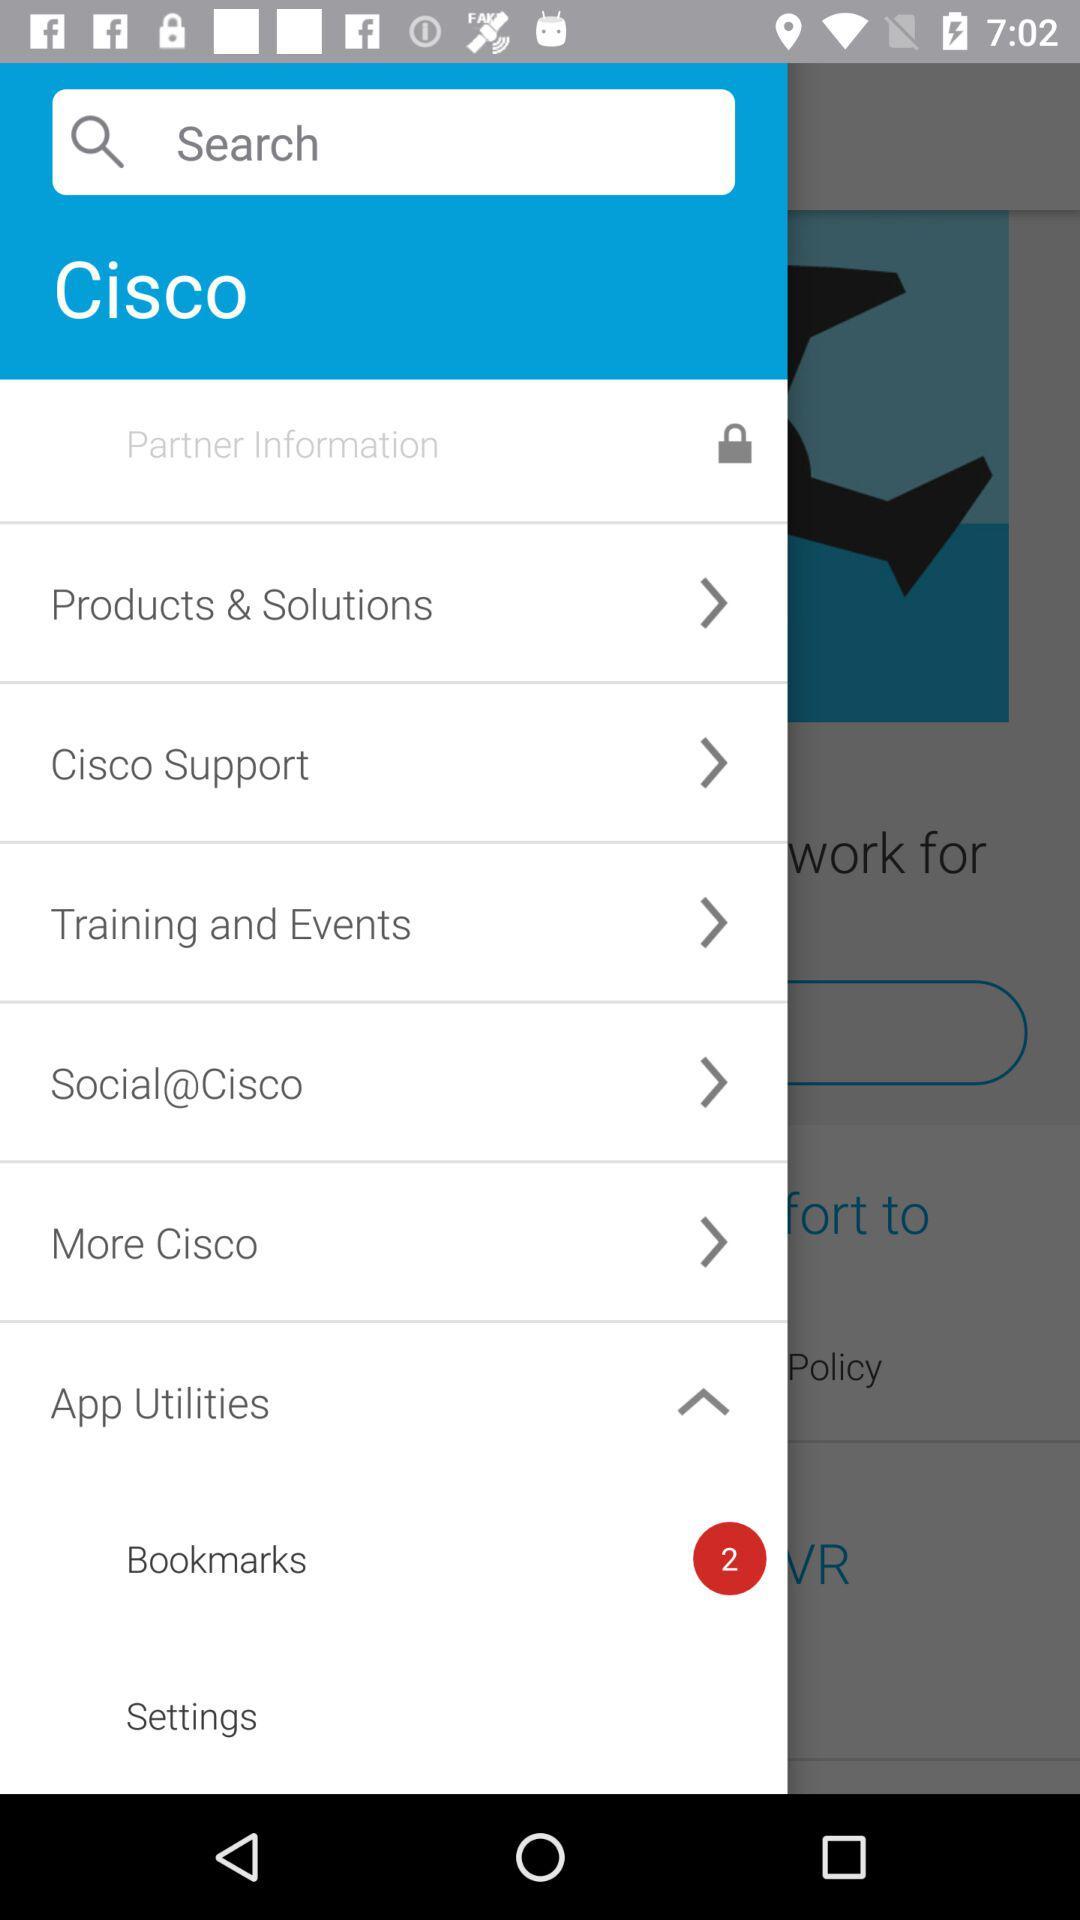What is the company name? The company name is "Cisco". 